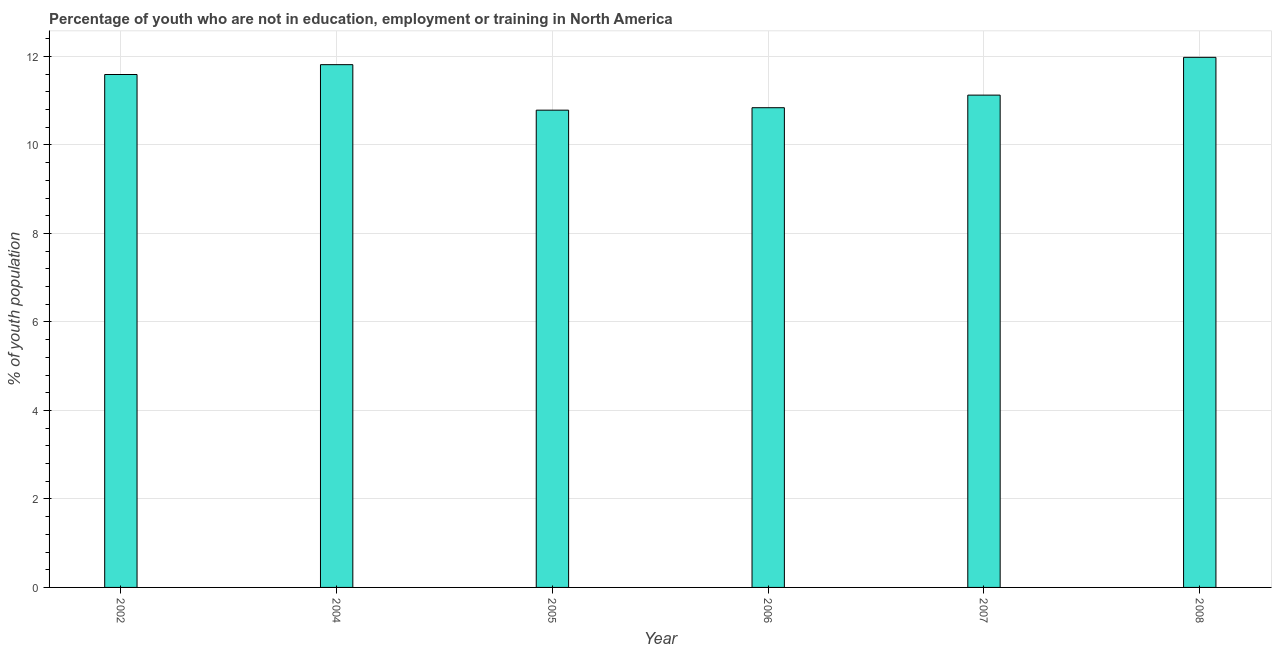Does the graph contain any zero values?
Offer a terse response. No. What is the title of the graph?
Your answer should be compact. Percentage of youth who are not in education, employment or training in North America. What is the label or title of the X-axis?
Your answer should be compact. Year. What is the label or title of the Y-axis?
Make the answer very short. % of youth population. What is the unemployed youth population in 2004?
Offer a very short reply. 11.81. Across all years, what is the maximum unemployed youth population?
Make the answer very short. 11.98. Across all years, what is the minimum unemployed youth population?
Your answer should be compact. 10.79. What is the sum of the unemployed youth population?
Your response must be concise. 68.14. What is the difference between the unemployed youth population in 2007 and 2008?
Offer a terse response. -0.85. What is the average unemployed youth population per year?
Your response must be concise. 11.36. What is the median unemployed youth population?
Your response must be concise. 11.36. In how many years, is the unemployed youth population greater than 6.8 %?
Your response must be concise. 6. Is the unemployed youth population in 2002 less than that in 2007?
Your response must be concise. No. What is the difference between the highest and the second highest unemployed youth population?
Provide a short and direct response. 0.17. Is the sum of the unemployed youth population in 2004 and 2008 greater than the maximum unemployed youth population across all years?
Keep it short and to the point. Yes. What is the difference between the highest and the lowest unemployed youth population?
Offer a terse response. 1.19. In how many years, is the unemployed youth population greater than the average unemployed youth population taken over all years?
Your response must be concise. 3. How many bars are there?
Your answer should be very brief. 6. Are all the bars in the graph horizontal?
Your answer should be compact. No. What is the difference between two consecutive major ticks on the Y-axis?
Offer a very short reply. 2. What is the % of youth population in 2002?
Make the answer very short. 11.59. What is the % of youth population in 2004?
Your answer should be compact. 11.81. What is the % of youth population in 2005?
Keep it short and to the point. 10.79. What is the % of youth population of 2006?
Provide a succinct answer. 10.84. What is the % of youth population of 2007?
Make the answer very short. 11.13. What is the % of youth population of 2008?
Provide a short and direct response. 11.98. What is the difference between the % of youth population in 2002 and 2004?
Your response must be concise. -0.22. What is the difference between the % of youth population in 2002 and 2005?
Provide a succinct answer. 0.81. What is the difference between the % of youth population in 2002 and 2006?
Provide a short and direct response. 0.75. What is the difference between the % of youth population in 2002 and 2007?
Your answer should be very brief. 0.47. What is the difference between the % of youth population in 2002 and 2008?
Ensure brevity in your answer.  -0.39. What is the difference between the % of youth population in 2004 and 2005?
Make the answer very short. 1.03. What is the difference between the % of youth population in 2004 and 2006?
Offer a terse response. 0.97. What is the difference between the % of youth population in 2004 and 2007?
Offer a terse response. 0.69. What is the difference between the % of youth population in 2004 and 2008?
Keep it short and to the point. -0.17. What is the difference between the % of youth population in 2005 and 2006?
Your answer should be very brief. -0.06. What is the difference between the % of youth population in 2005 and 2007?
Ensure brevity in your answer.  -0.34. What is the difference between the % of youth population in 2005 and 2008?
Keep it short and to the point. -1.19. What is the difference between the % of youth population in 2006 and 2007?
Keep it short and to the point. -0.28. What is the difference between the % of youth population in 2006 and 2008?
Keep it short and to the point. -1.14. What is the difference between the % of youth population in 2007 and 2008?
Provide a succinct answer. -0.85. What is the ratio of the % of youth population in 2002 to that in 2005?
Your response must be concise. 1.07. What is the ratio of the % of youth population in 2002 to that in 2006?
Ensure brevity in your answer.  1.07. What is the ratio of the % of youth population in 2002 to that in 2007?
Keep it short and to the point. 1.04. What is the ratio of the % of youth population in 2002 to that in 2008?
Your answer should be compact. 0.97. What is the ratio of the % of youth population in 2004 to that in 2005?
Offer a terse response. 1.09. What is the ratio of the % of youth population in 2004 to that in 2006?
Keep it short and to the point. 1.09. What is the ratio of the % of youth population in 2004 to that in 2007?
Provide a short and direct response. 1.06. What is the ratio of the % of youth population in 2005 to that in 2008?
Make the answer very short. 0.9. What is the ratio of the % of youth population in 2006 to that in 2008?
Provide a succinct answer. 0.91. What is the ratio of the % of youth population in 2007 to that in 2008?
Your answer should be compact. 0.93. 